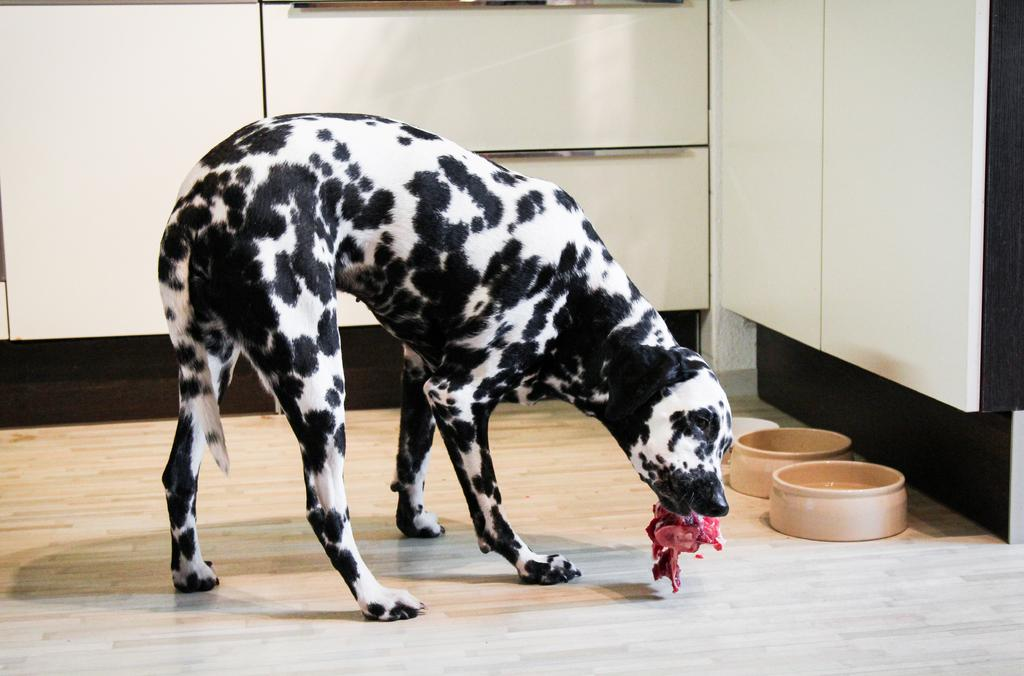What type of animal is in the image? There is a dog in the image. What is the dog doing in the image? The dog is standing in the image. What is the dog holding in its mouth? The dog has a piece of meat in its mouth. What objects are on the floor in the image? There are two bowls on the floor in the image. What type of line can be seen at the seashore in the image? There is no seashore or line present in the image; it features a dog standing with a piece of meat in its mouth and two bowls on the floor. 